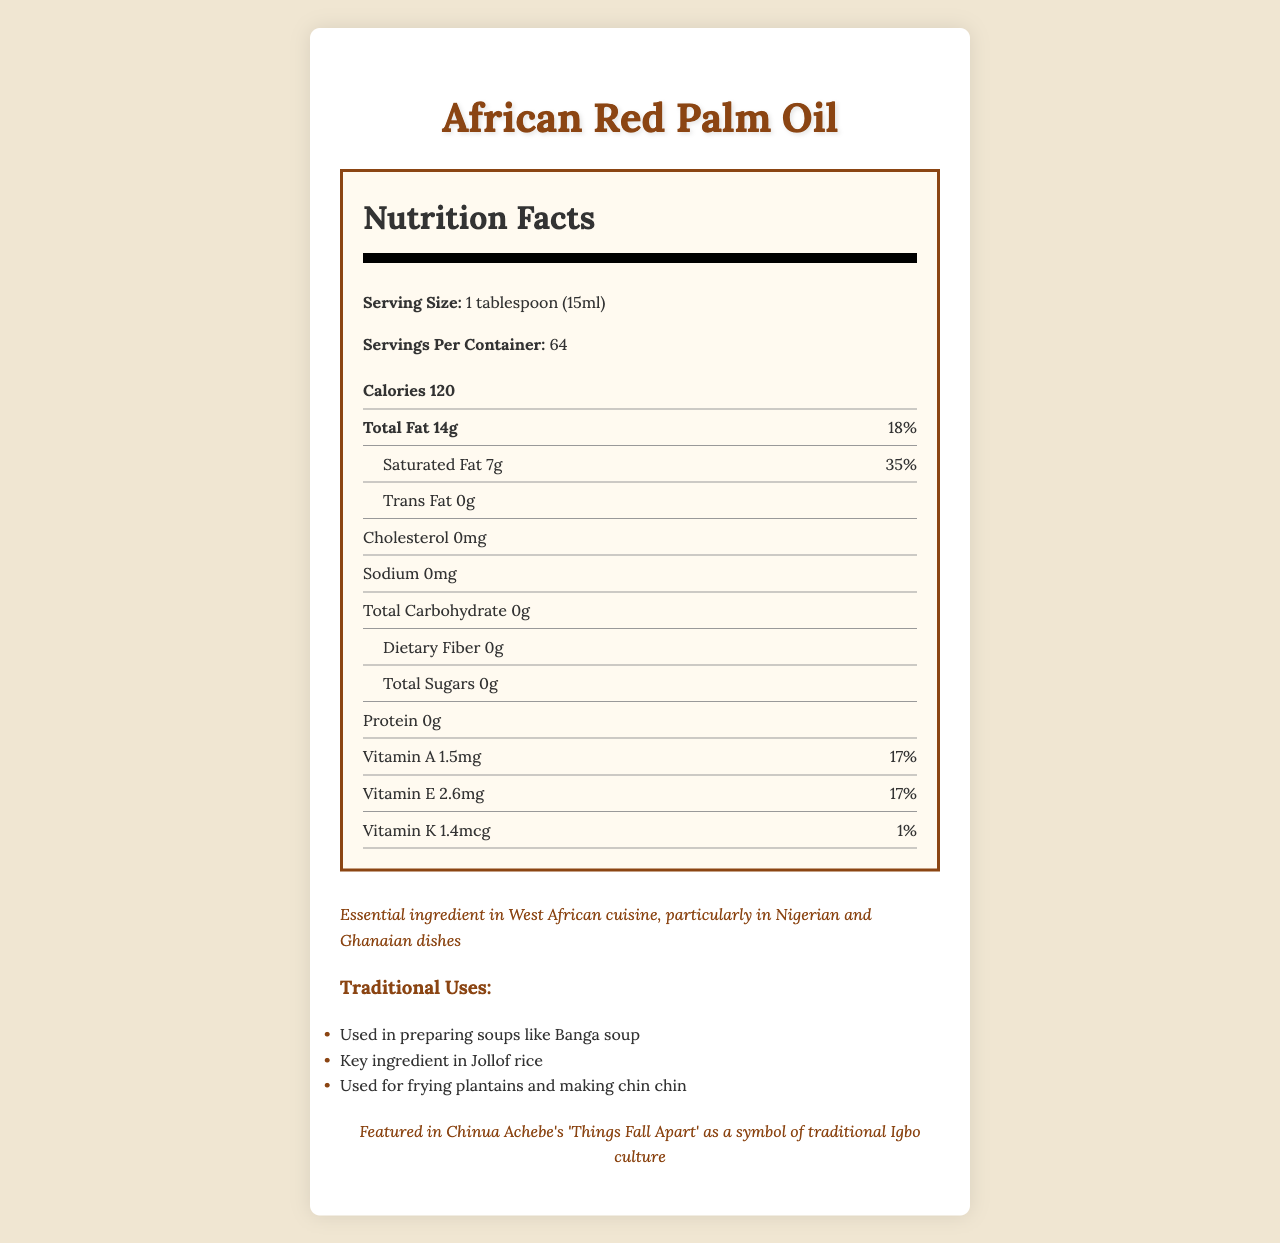what is the serving size of African Red Palm Oil? The serving size is specified as "1 tablespoon (15ml)" in the Nutrition Facts section.
Answer: 1 tablespoon (15ml) how many calories are there per serving? The Nutrition Facts label states that there are 120 calories per serving.
Answer: 120 what percentage of the daily value of saturated fat does one serving contribute? The Nutrition Facts label indicates that one serving contributes 35% of the daily value of saturated fat.
Answer: 35% what is the total amount of fat in one serving? The Nutrition Facts label lists the total fat per serving as 14 grams.
Answer: 14g how much Vitamin A is in one serving of African Red Palm Oil? The Nutrition Facts label states that each serving contains 1.5mg of Vitamin A.
Answer: 1.5mg how many servings are there per container? The Nutrition Facts label specifies that there are 64 servings per container.
Answer: 64 which nutrient in African Red Palm Oil has the highest daily value percentage per serving? A. Vitamin E B. Vitamin A C. Saturated Fat D. Dietary Fiber Saturated fat has a daily value of 35%, which is the highest percentage compared to Vitamin E (17%), Vitamin A (17%), and Dietary Fiber (0%).
Answer: C. Saturated Fat what are some traditional uses of African Red Palm Oil? A. Frying plantains B. Making chin chin C. Preparing Banga soup D. All of the above The document lists frying plantains, making chin chin, and preparing Banga soup as traditional uses of African Red Palm Oil.
Answer: D. All of the above is trans fat present in African Red Palm Oil? The Nutrition Facts label states that there are 0 grams of trans fat per serving.
Answer: No do you think consuming African Red Palm Oil can be part of a balanced diet even though it is high in saturated fat? The document mentions that, while high in saturated fat, palm oil is rich in antioxidants and can be part of a balanced diet when used in moderation.
Answer: Yes summarize the key points of the document regarding African Red Palm Oil. The document highlights the nutritional content of African Red Palm Oil, its cultural significance, traditional uses, health considerations, and sustainable sourcing. It mentions its high saturated fat content alongside its benefits, such as antioxidants and vitamins.
Answer: African Red Palm Oil is high in saturated fat, providing 35% of the daily value per serving. It is an essential ingredient in West African cuisine, used in dishes like Banga soup and Jollof rice. Despite its high saturated fat content, it contains beneficial antioxidants and vitamins A, E, and K. It supports local communities in Ghana through small-scale farming. how many grams of carbohydrates are in a serving of African Red Palm Oil? The Nutrition Facts label shows that there are 0 grams of carbohydrates per serving.
Answer: 0g what are the health considerations mentioned for consuming African Red Palm Oil? The document states that African Red Palm Oil is high in saturated fat, which may increase cholesterol levels if consumed excessively.
Answer: High in saturated fat, which may contribute to increased cholesterol levels if consumed in excess who is the document supporting through the sustainability note? The sustainability note mentions that the palm oil is sourced from small-scale farmers in Ghana, supporting local communities.
Answer: Local communities in Ghana which vitamin is present in the least amount per serving? A. Vitamin A B. Vitamin E C. Vitamin K Vitamin K is present in the least amount per serving, with only 1.4mcg and a daily value of 1%.
Answer: C. Vitamin K is African Red Palm Oil's use mentioned in any literary works? If so, which one? The document mentions that African Red Palm Oil is featured in Chinua Achebe's 'Things Fall Apart' as a symbol of traditional Igbo culture.
Answer: Yes, 'Things Fall Apart' by Chinua Achebe what are the protein content and cholesterol content per serving in African Red Palm Oil? The Nutrition Facts label specifies that there are 0 grams of protein and 0 milligrams of cholesterol per serving.
Answer: 0g of protein and 0mg of cholesterol where in the document does the reference to Nigerian and Ghanaian dishes come from? The document mentions Nigerian and Ghanaian dishes as part of the cultural significance section.
Answer: In the "Cultural Significance" section what is the ratio of saturated fat to total fat in one serving? From the Nutrition Facts label, the saturated fat is 7 grams out of a total fat of 14 grams per serving, giving a 1:2 ratio.
Answer: 7g of saturated fat to 14g of total fat 